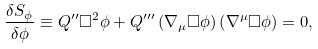Convert formula to latex. <formula><loc_0><loc_0><loc_500><loc_500>\frac { \delta S _ { \phi } } { \delta \phi } \equiv Q ^ { \prime \prime } \Box ^ { 2 } \phi + Q ^ { \prime \prime \prime } \left ( \nabla _ { \mu } \Box \phi \right ) \left ( \nabla ^ { \mu } \Box \phi \right ) = 0 ,</formula> 